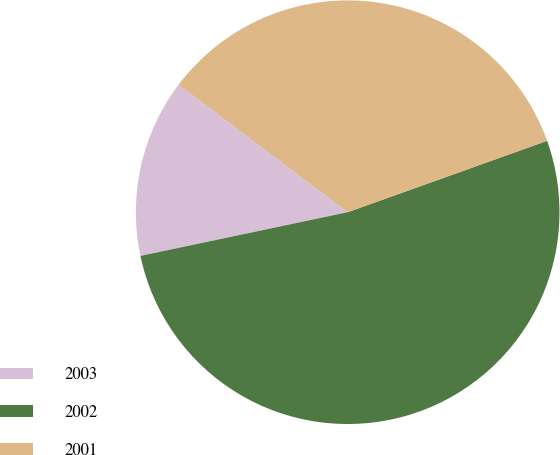<chart> <loc_0><loc_0><loc_500><loc_500><pie_chart><fcel>2003<fcel>2002<fcel>2001<nl><fcel>13.58%<fcel>52.17%<fcel>34.26%<nl></chart> 